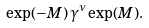<formula> <loc_0><loc_0><loc_500><loc_500>\exp ( - M ) \, \gamma ^ { \nu } \exp ( M ) .</formula> 